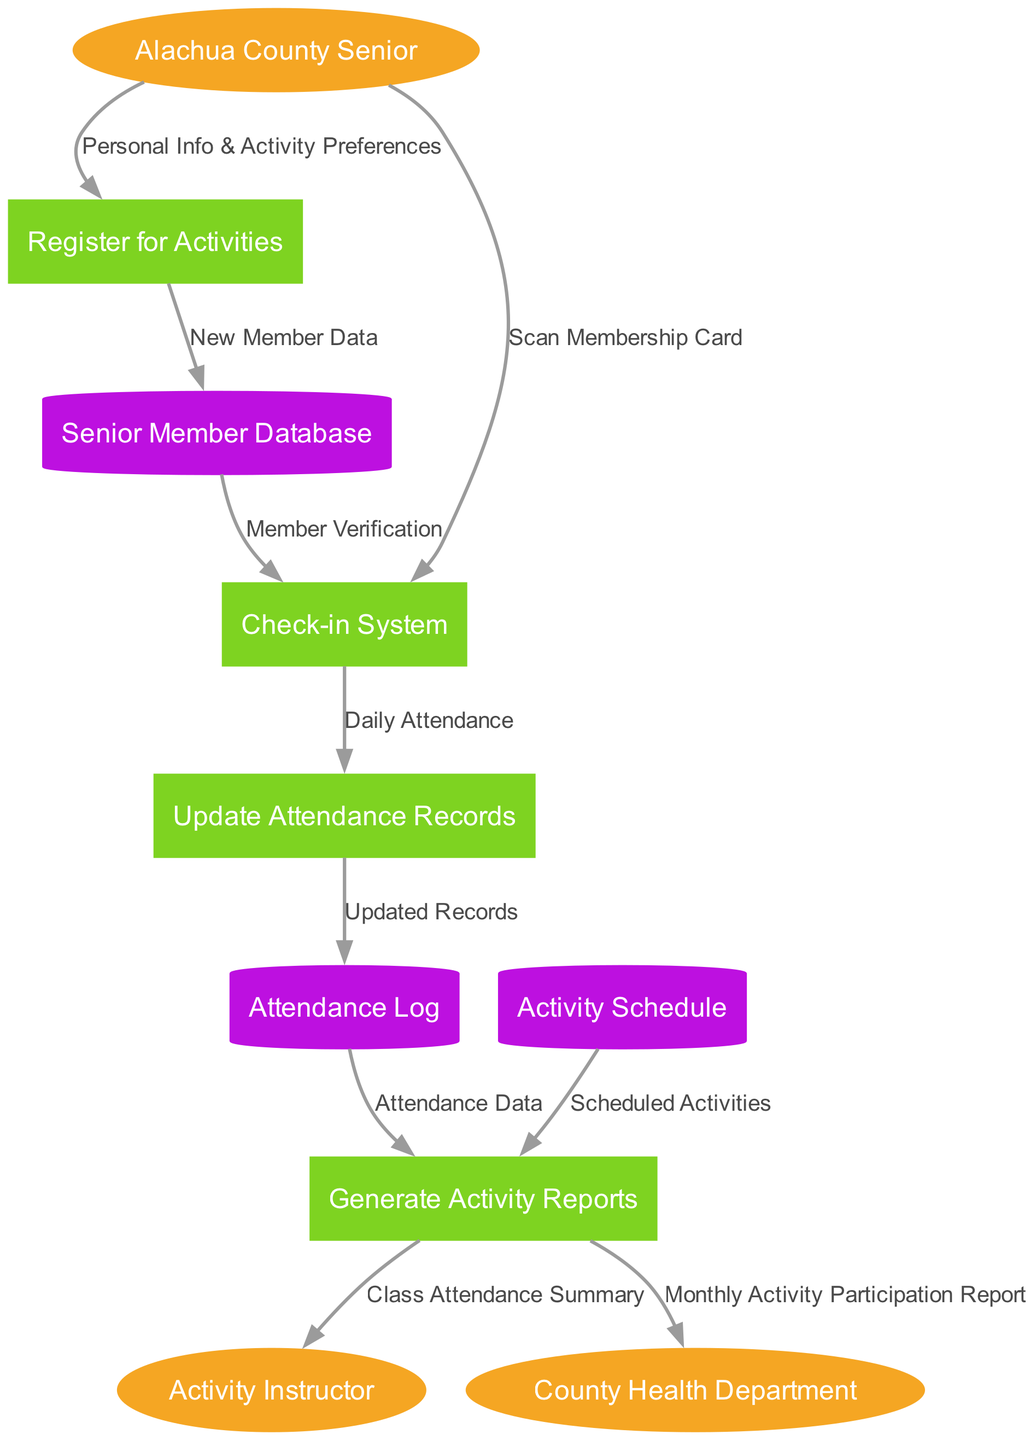What are the external entities in the diagram? The external entities listed in the diagram are "Alachua County Senior," "Activity Instructor," and "County Health Department." These entities are represented as ellipses.
Answer: Alachua County Senior, Activity Instructor, County Health Department How many processes are in the diagram? By counting the processes defined in the diagram, we find there are four distinct processes: "Register for Activities," "Check-in System," "Update Attendance Records," and "Generate Activity Reports."
Answer: Four What data is sent from the "Alachua County Senior" to the "Check-in System"? The diagram indicates that "Personal Info & Activity Preferences" is sent from "Alachua County Senior" to "Register for Activities," and "Scan Membership Card" is sent directly to the "Check-in System."
Answer: Scan Membership Card Which process generates reports using data from the "Attendance Log"? According to the diagram, the process "Generate Activity Reports" utilizes data that is flowing from the "Attendance Log," among other sources, to create reports.
Answer: Generate Activity Reports What type of data store is "Senior Member Database"? In the diagram, "Senior Member Database" is represented as a cylinder, which characterizes it as a data store within the flow of information.
Answer: Cylinder What flows into "Update Attendance Records"? The flow into "Update Attendance Records" comes from the "Check-in System," labeled as "Daily Attendance." This indicates that daily attendance data is used to update records.
Answer: Daily Attendance What is the outcome of the "Generate Activity Reports"? The outputs of the "Generate Activity Reports" process include a “Class Attendance Summary” that is sent to the "Activity Instructor" and a “Monthly Activity Participation Report” sent to the "County Health Department."
Answer: Class Attendance Summary, Monthly Activity Participation Report How many data stores are present in the diagram? The diagram outlines three data stores: "Senior Member Database," "Activity Schedule," and "Attendance Log." By counting these, we can conclude that there are three data stores in total.
Answer: Three What is the relationship between "Register for Activities" and "Senior Member Database"? The diagram illustrates that the "Register for Activities" process sends "New Member Data" to the "Senior Member Database," indicating a direct flow of new registration information.
Answer: New Member Data 